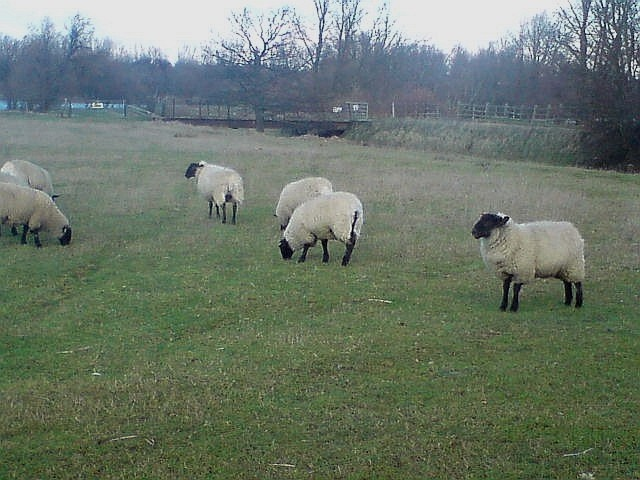Describe the objects in this image and their specific colors. I can see sheep in lightgray, darkgray, gray, and black tones, sheep in lightgray, darkgray, gray, and black tones, sheep in lightgray, gray, darkgray, and black tones, sheep in lightgray, darkgray, gray, and black tones, and sheep in lightgray, darkgray, and gray tones in this image. 